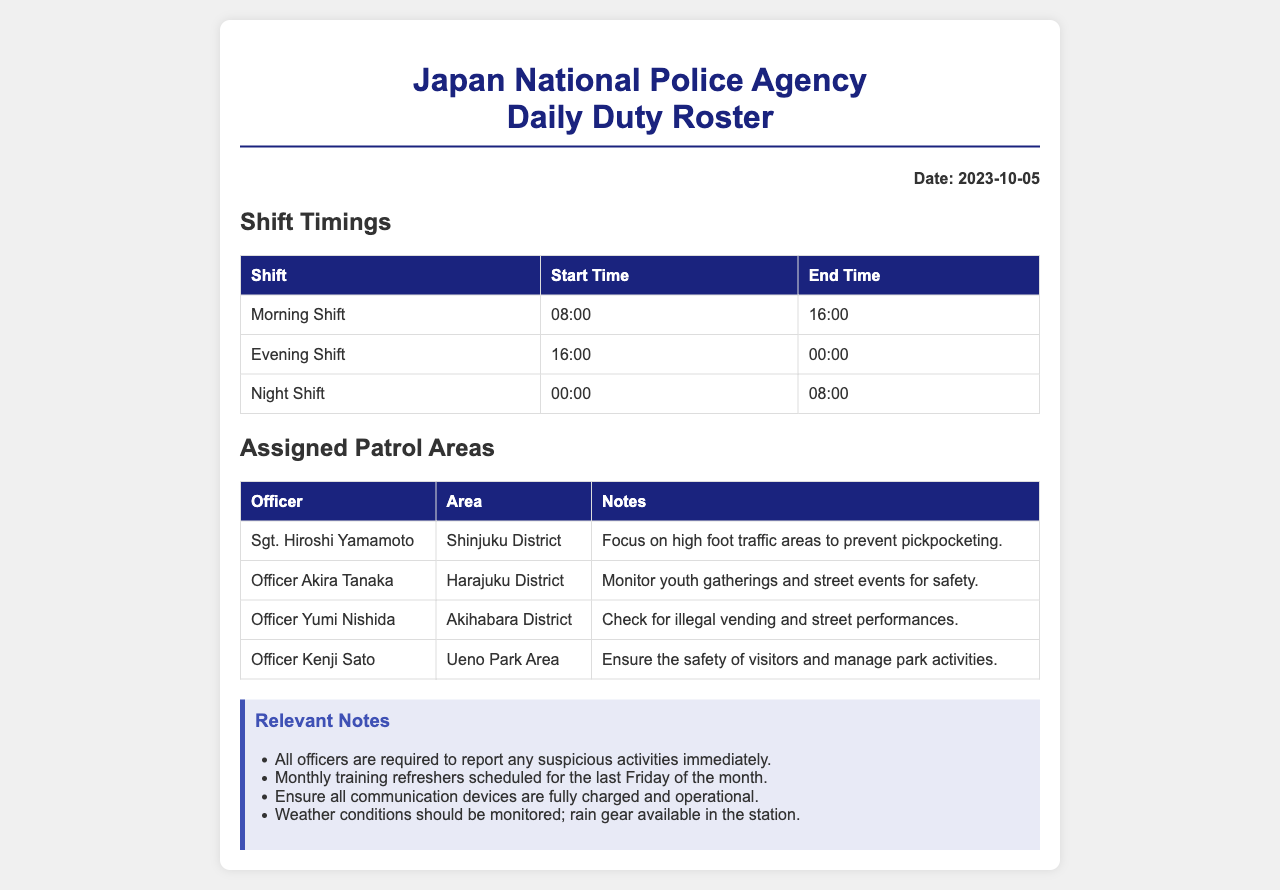What is the date of the duty roster? The date is stated at the top of the document under the "Date" section.
Answer: 2023-10-05 What are the timings for the Evening Shift? The shift timings are provided in the shift timing table under the "Shift" section.
Answer: 16:00 to 00:00 Who is assigned to patrol the Akihabara District? The assigned officer is mentioned in the table under the "Assigned Patrol Areas" section.
Answer: Officer Yumi Nishida What is the main focus for Sgt. Hiroshi Yamamoto during his patrol? The notes section for each officer specifies the focus for their patrol areas.
Answer: High foot traffic areas to prevent pickpocketing How many officers are listed in the Assigned Patrol Areas table? The total number of officers can be found by counting the rows in the table under the "Assigned Patrol Areas."
Answer: 4 What is one of the relevant notes mentioned in the document? Relevant notes can be found in the notes section at the bottom of the document.
Answer: All officers are required to report any suspicious activities immediately What is the start time for the Morning Shift? The start time is mentioned in the shift timings table.
Answer: 08:00 Which district is Officer Akira Tanaka assigned to? The assigned area for each officer is specified in the "Assigned Patrol Areas" table.
Answer: Harajuku District 